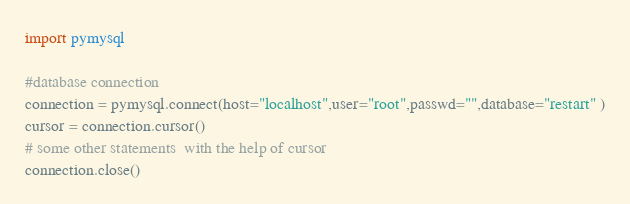Convert code to text. <code><loc_0><loc_0><loc_500><loc_500><_Python_>import pymysql

#database connection
connection = pymysql.connect(host="localhost",user="root",passwd="",database="restart" )
cursor = connection.cursor()
# some other statements  with the help of cursor
connection.close()</code> 